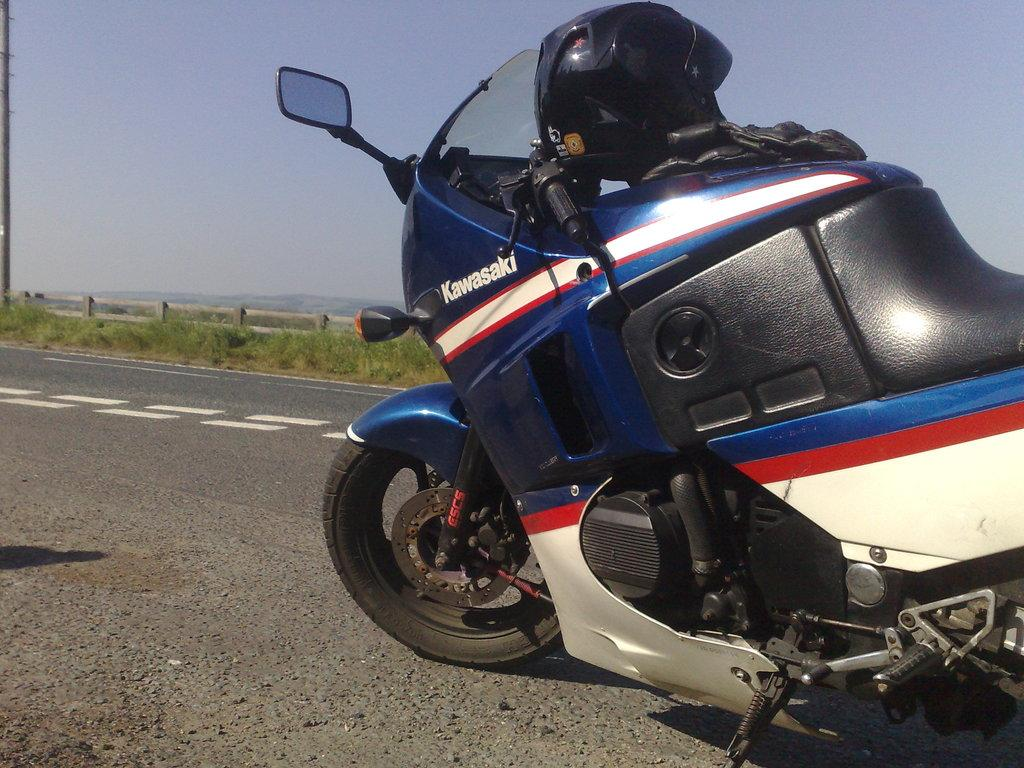What is the main subject of the image? The main subject of the image is a motorbike. Where is the motorbike located? The motorbike is on the road. What safety equipment is present on the motorbike? There is a helmet and gloves on the motorbike. What can be seen in the background of the image? In the background of the image, there are plants, a pole, a fence, and the sky. What type of destruction can be seen happening to the plate in the image? There is no plate present in the image, so it is not possible to determine any destruction happening to it. 